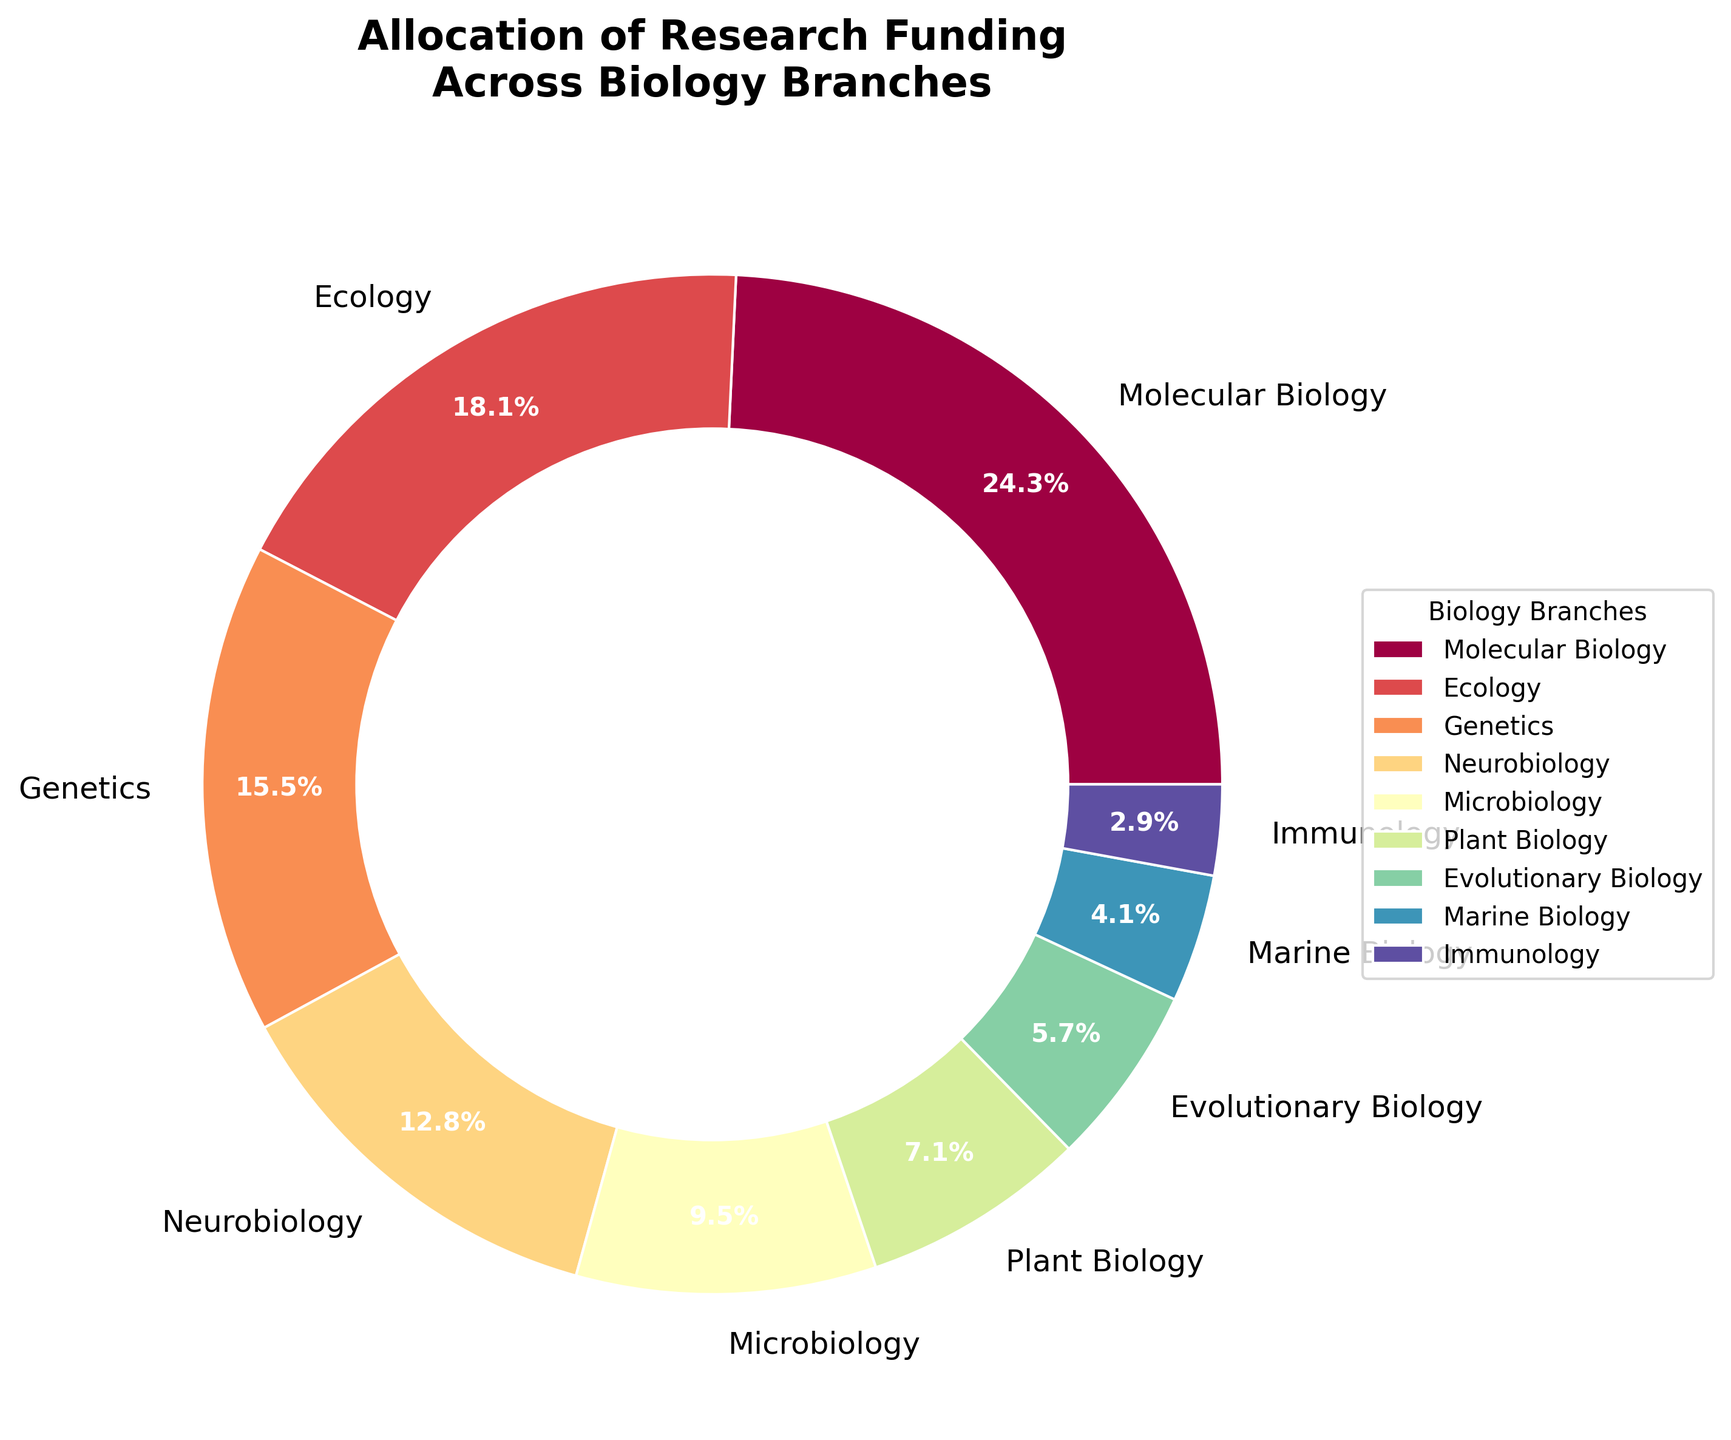Which branch of biology receives the highest research funding percentage? By observing the pie chart, locate the sector with the largest area or the highest percentage label. This represents the branch receiving the most funding.
Answer: Molecular Biology Which branch receives more funding: Neurobiology or Plant Biology? Compare the funding percentages for Neurobiology and Plant Biology shown on the chart. Neurobiology receives 12.9%, and Plant Biology receives 7.2%.
Answer: Neurobiology What is the combined funding percentage for Microbiology and Immunology? Sum the funding percentages for Microbiology (9.6%) and Immunology (2.9%). 9.6 + 2.9 = 12.5.
Answer: 12.5% Which branch receives the least funding? Identify the smallest labeled sector on the pie chart, which represents the branch receiving the least funding. The smallest percentage mentioned is 2.9%.
Answer: Immunology How much more funding does Molecular Biology receive compared to Marine Biology? Subtract the funding percentage of Marine Biology (4.1%) from that of Molecular Biology (24.5%). 24.5 - 4.1 = 20.4.
Answer: 20.4% What is the total funding allocated to Ecology, Genetics, and Marine Biology? Add the funding percentages of Ecology (18.3%), Genetics (15.7%), and Marine Biology (4.1%). 18.3 + 15.7 + 4.1 = 38.1.
Answer: 38.1% Are there any branches receiving similar funding percentages? Compare the funding percentages across the branches to identify similar values, especially those visually close in size on the pie chart. Notice the values for Ecology (18.3%) and Genetics (15.7%) are close, but not identical.
Answer: No What percentage of funding is allocated outside of the top three branches (Molecular Biology, Ecology, and Genetics)? Find the sum of the percentages for the top three branches: Molecular Biology (24.5%), Ecology (18.3%), and Genetics (15.7%). Subtract this sum from 100%. 24.5 + 18.3 + 15.7 = 58.5; 100 - 58.5 = 41.5%.
Answer: 41.5% Which two branches together receive more funding than Genetics? Since Genetics receives 15.7%, find pairs of branches that together exceed this percentage. For instance, Microbiology (9.6%) and Plant Biology (7.2%) together receive 16.8%, which is more than 15.7%.
Answer: Microbiology and Plant Biology 